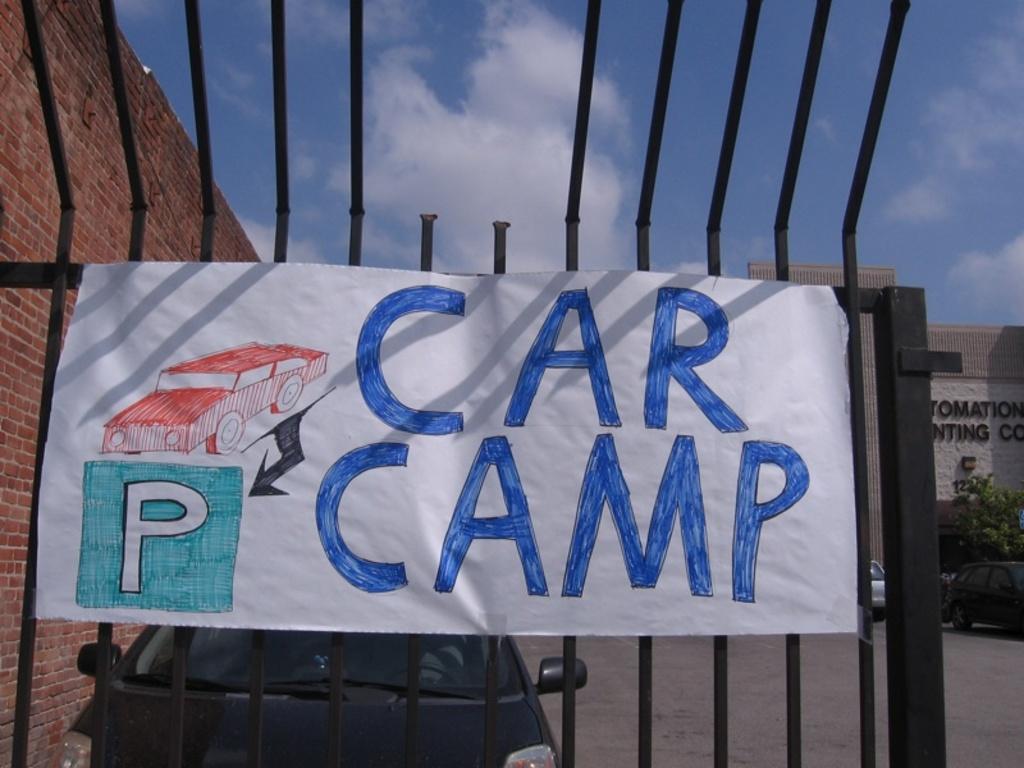How would you summarize this image in a sentence or two? In this image we can see sky with clouds, wall, building, plant, motor vehicles on the road and a sign board attached to the grills. 